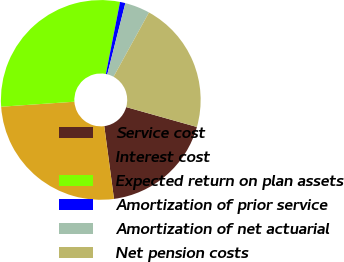Convert chart to OTSL. <chart><loc_0><loc_0><loc_500><loc_500><pie_chart><fcel>Service cost<fcel>Interest cost<fcel>Expected return on plan assets<fcel>Amortization of prior service<fcel>Amortization of net actuarial<fcel>Net pension costs<nl><fcel>18.52%<fcel>26.03%<fcel>29.17%<fcel>0.87%<fcel>4.06%<fcel>21.35%<nl></chart> 